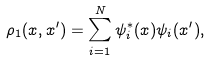Convert formula to latex. <formula><loc_0><loc_0><loc_500><loc_500>\rho _ { 1 } ( x , x ^ { \prime } ) = \sum _ { i = 1 } ^ { N } \psi _ { i } ^ { * } ( x ) \psi _ { i } ( x ^ { \prime } ) ,</formula> 